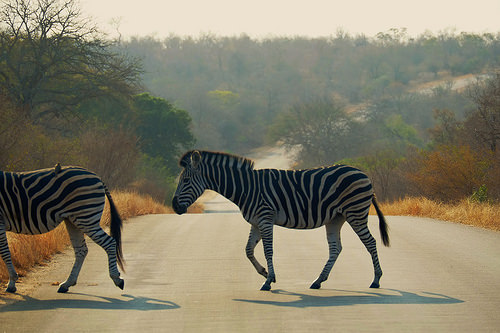<image>
Is there a zebra in front of the tree? Yes. The zebra is positioned in front of the tree, appearing closer to the camera viewpoint. 